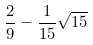Convert formula to latex. <formula><loc_0><loc_0><loc_500><loc_500>\frac { 2 } { 9 } - \frac { 1 } { 1 5 } \sqrt { 1 5 }</formula> 